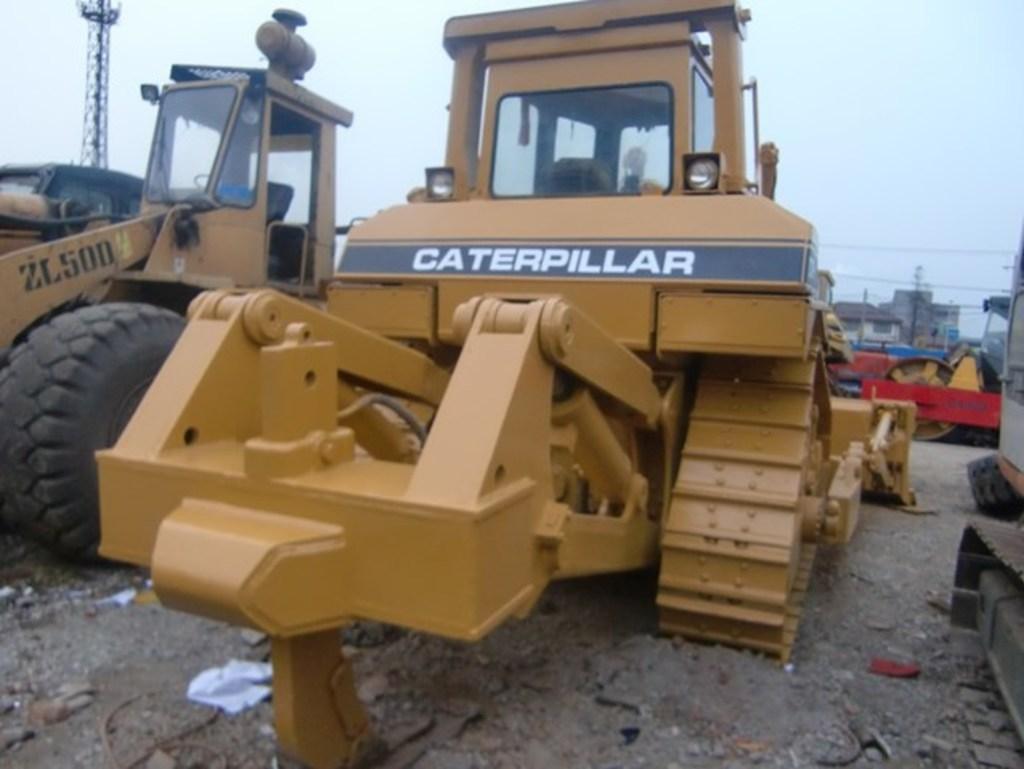Could you give a brief overview of what you see in this image? In the center of the image there are proclaimers. At the bottom of the image there is ground. In the background of the image there is sky. There is a tower. 